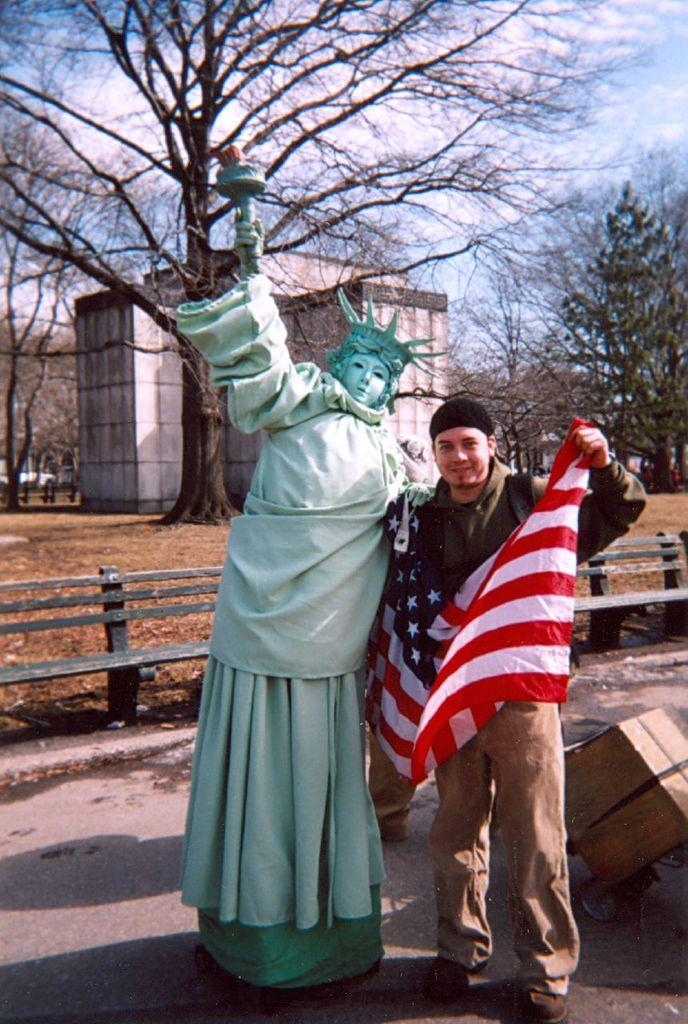What is the man in the image holding? The man is holding a flag. What is located beside the man in the image? There is a statue beside the man. What can be seen in the background of the image? There are trees, a building, and clouds visible in the background of the image. How many books can be seen stacked on the bone in the image? There are no books or bones present in the image. 